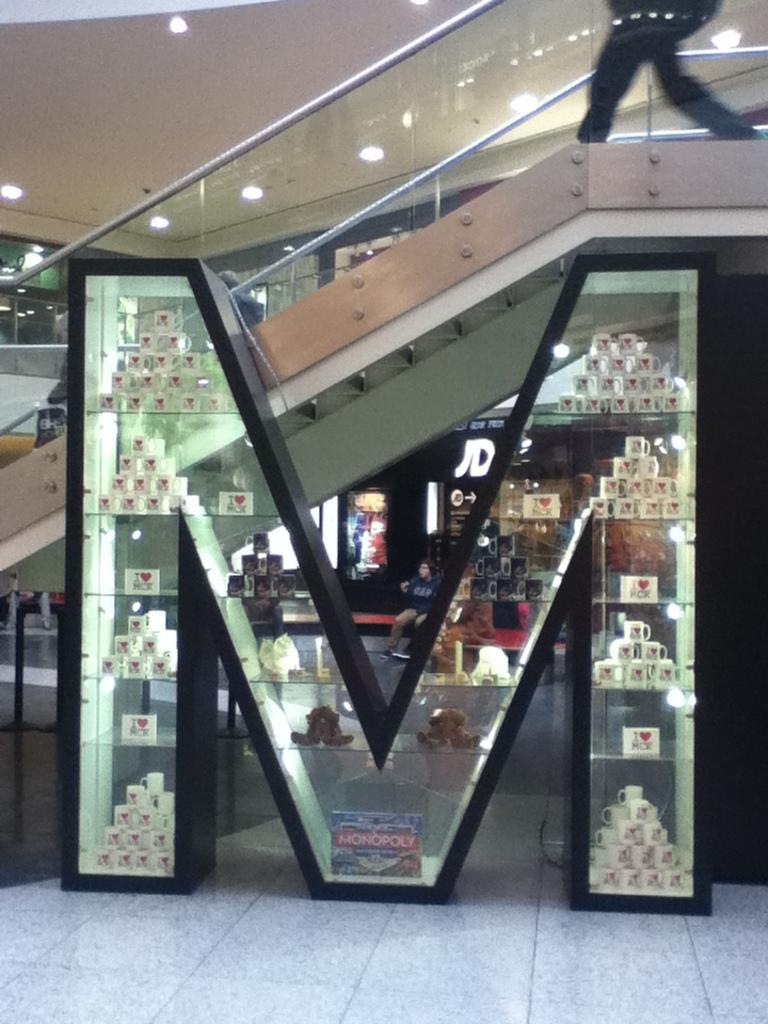Could you give a brief overview of what you see in this image? In this image, we can see my letter glass cupboard. So many cups are on the racks. At the bottom, we can see the floor. Background we can see few stalls, few peoples. Here we can see glass, rods, lights. A person is walking here. 